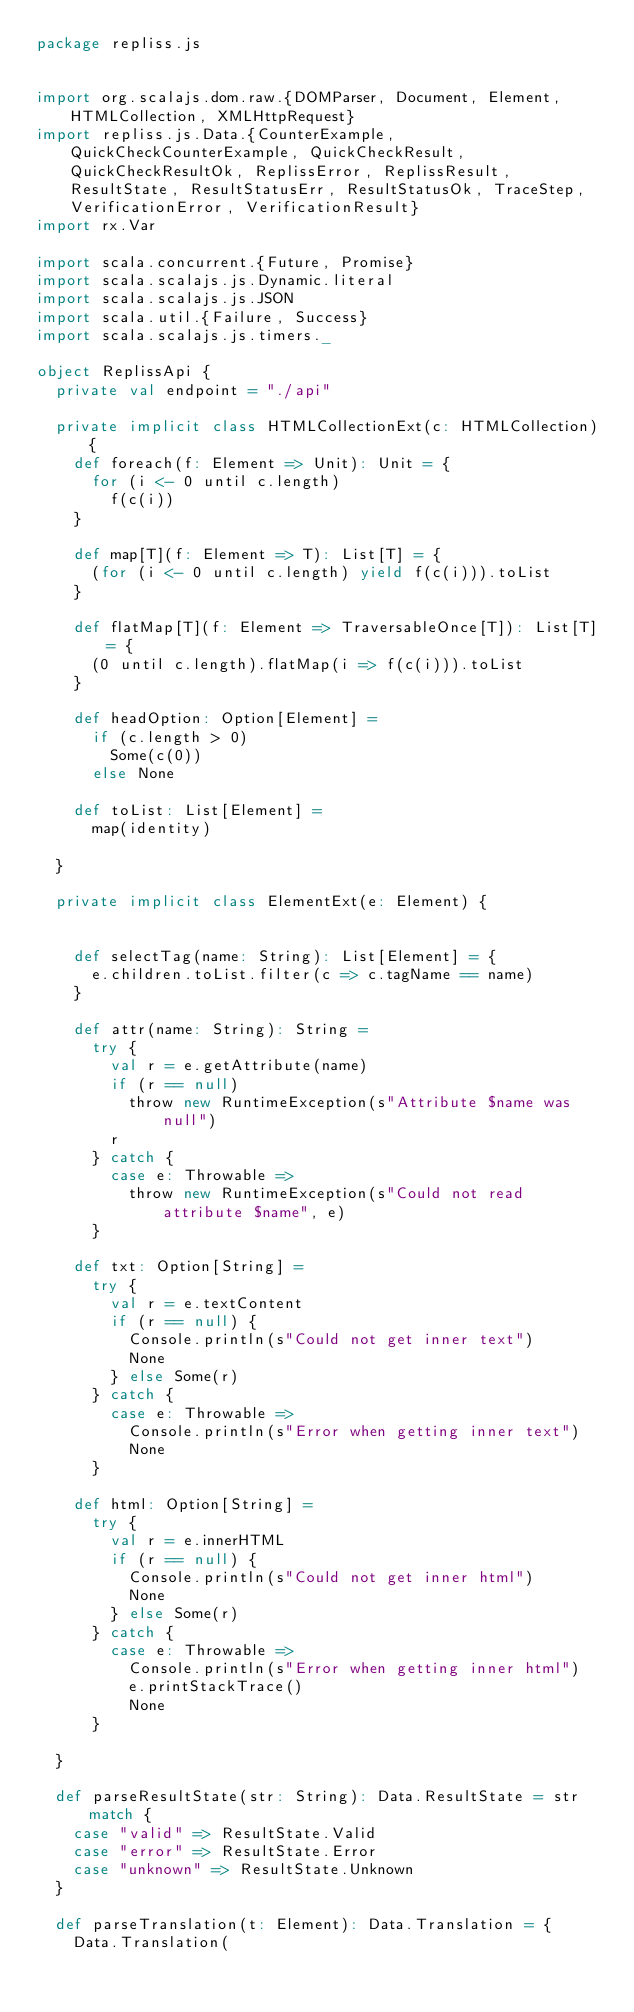<code> <loc_0><loc_0><loc_500><loc_500><_Scala_>package repliss.js


import org.scalajs.dom.raw.{DOMParser, Document, Element, HTMLCollection, XMLHttpRequest}
import repliss.js.Data.{CounterExample, QuickCheckCounterExample, QuickCheckResult, QuickCheckResultOk, ReplissError, ReplissResult, ResultState, ResultStatusErr, ResultStatusOk, TraceStep, VerificationError, VerificationResult}
import rx.Var

import scala.concurrent.{Future, Promise}
import scala.scalajs.js.Dynamic.literal
import scala.scalajs.js.JSON
import scala.util.{Failure, Success}
import scala.scalajs.js.timers._

object ReplissApi {
  private val endpoint = "./api"

  private implicit class HTMLCollectionExt(c: HTMLCollection) {
    def foreach(f: Element => Unit): Unit = {
      for (i <- 0 until c.length)
        f(c(i))
    }

    def map[T](f: Element => T): List[T] = {
      (for (i <- 0 until c.length) yield f(c(i))).toList
    }

    def flatMap[T](f: Element => TraversableOnce[T]): List[T] = {
      (0 until c.length).flatMap(i => f(c(i))).toList
    }

    def headOption: Option[Element] =
      if (c.length > 0)
        Some(c(0))
      else None

    def toList: List[Element] =
      map(identity)

  }

  private implicit class ElementExt(e: Element) {


    def selectTag(name: String): List[Element] = {
      e.children.toList.filter(c => c.tagName == name)
    }

    def attr(name: String): String =
      try {
        val r = e.getAttribute(name)
        if (r == null)
          throw new RuntimeException(s"Attribute $name was null")
        r
      } catch {
        case e: Throwable =>
          throw new RuntimeException(s"Could not read attribute $name", e)
      }

    def txt: Option[String] =
      try {
        val r = e.textContent
        if (r == null) {
          Console.println(s"Could not get inner text")
          None
        } else Some(r)
      } catch {
        case e: Throwable =>
          Console.println(s"Error when getting inner text")
          None
      }

    def html: Option[String] =
      try {
        val r = e.innerHTML
        if (r == null) {
          Console.println(s"Could not get inner html")
          None
        } else Some(r)
      } catch {
        case e: Throwable =>
          Console.println(s"Error when getting inner html")
          e.printStackTrace()
          None
      }

  }

  def parseResultState(str: String): Data.ResultState = str match {
    case "valid" => ResultState.Valid
    case "error" => ResultState.Error
    case "unknown" => ResultState.Unknown
  }

  def parseTranslation(t: Element): Data.Translation = {
    Data.Translation(</code> 